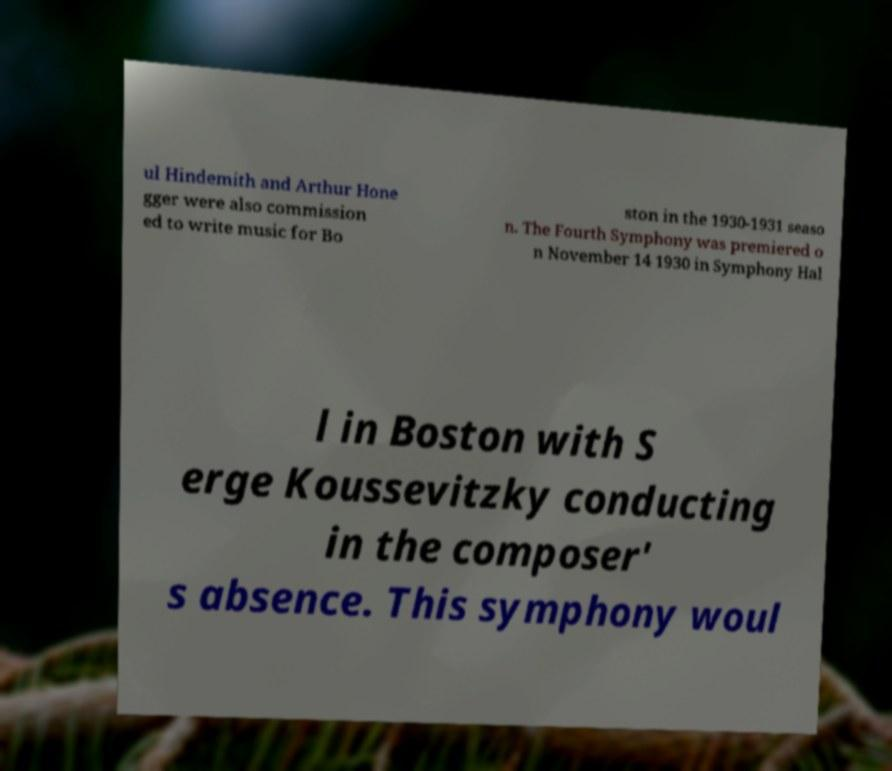What messages or text are displayed in this image? I need them in a readable, typed format. ul Hindemith and Arthur Hone gger were also commission ed to write music for Bo ston in the 1930-1931 seaso n. The Fourth Symphony was premiered o n November 14 1930 in Symphony Hal l in Boston with S erge Koussevitzky conducting in the composer' s absence. This symphony woul 